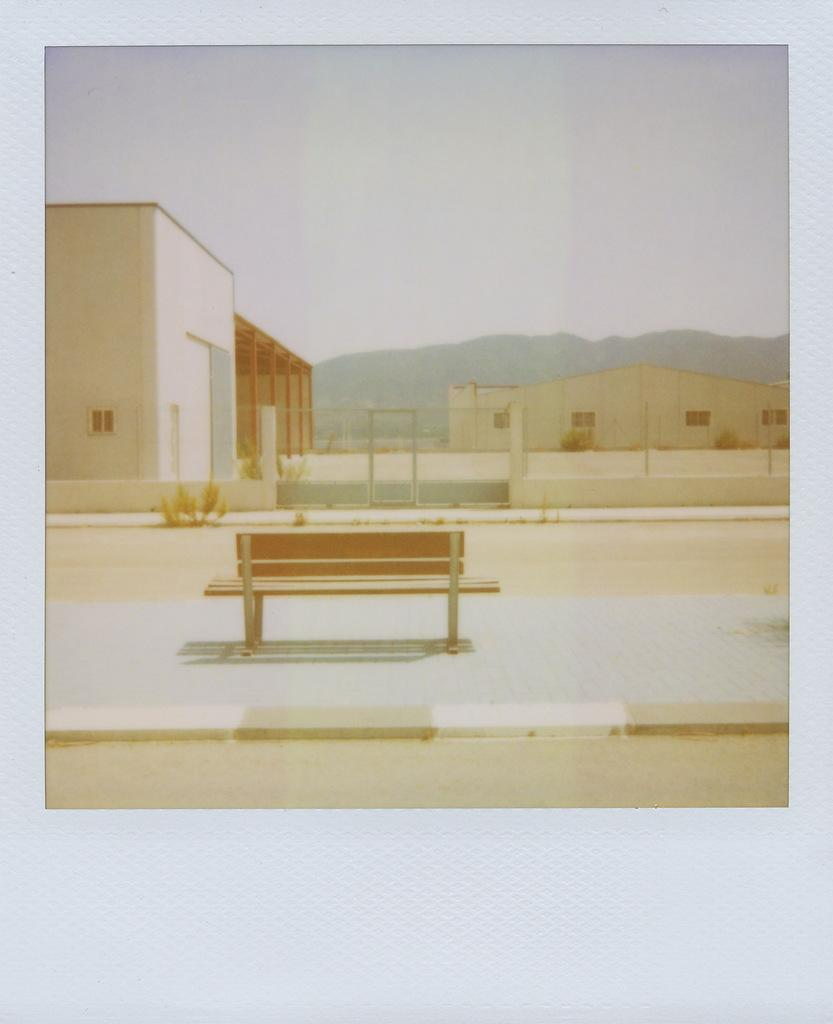What type of structures can be seen in the image? There are buildings in the image. What other elements are present in the image besides buildings? There are plants, a bench, a metal fence, and a hill in the image. What is the condition of the sky in the image? The sky is cloudy in the image. Can you tell me how many goldfish are swimming in the pond in the image? There is no pond or goldfish present in the image. What type of organization is responsible for maintaining the metal fence in the image? There is no information about an organization responsible for maintaining the metal fence in the image. 